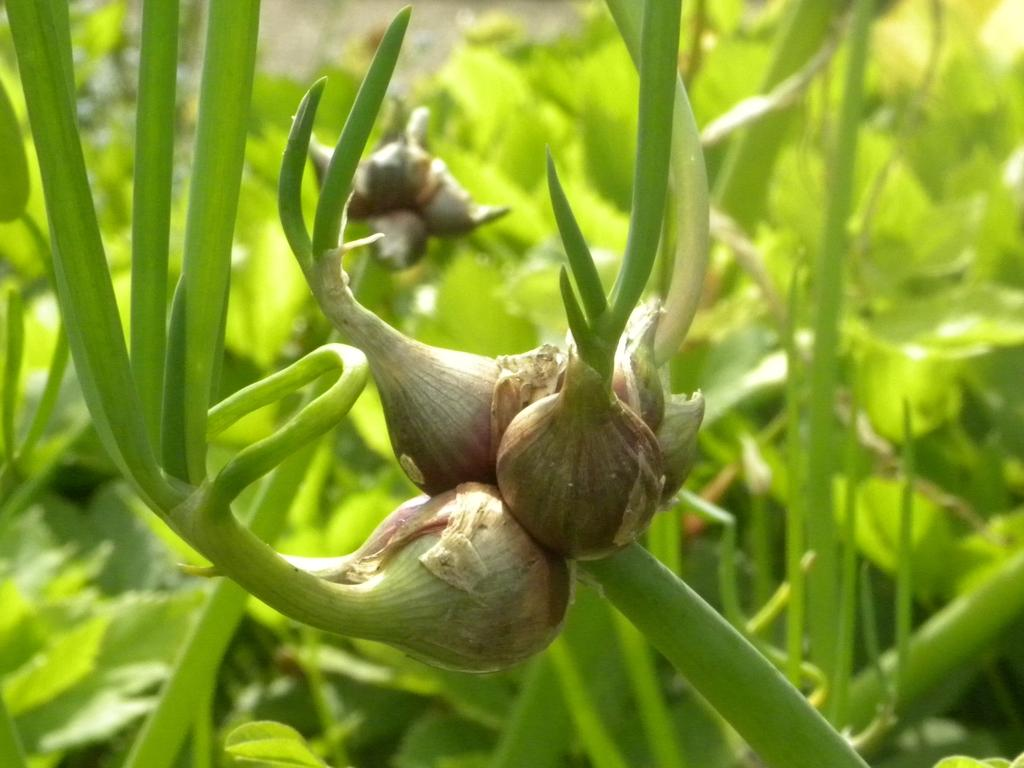What type of vegetable is present in the image? There are onions in the image. What other living organisms can be seen in the image? There are plants in the image. What type of star can be seen in the image? There is no star present in the image; it only features onions and plants. What season is depicted in the image? The image does not depict a specific season, as there is no indication of weather or time of year. 